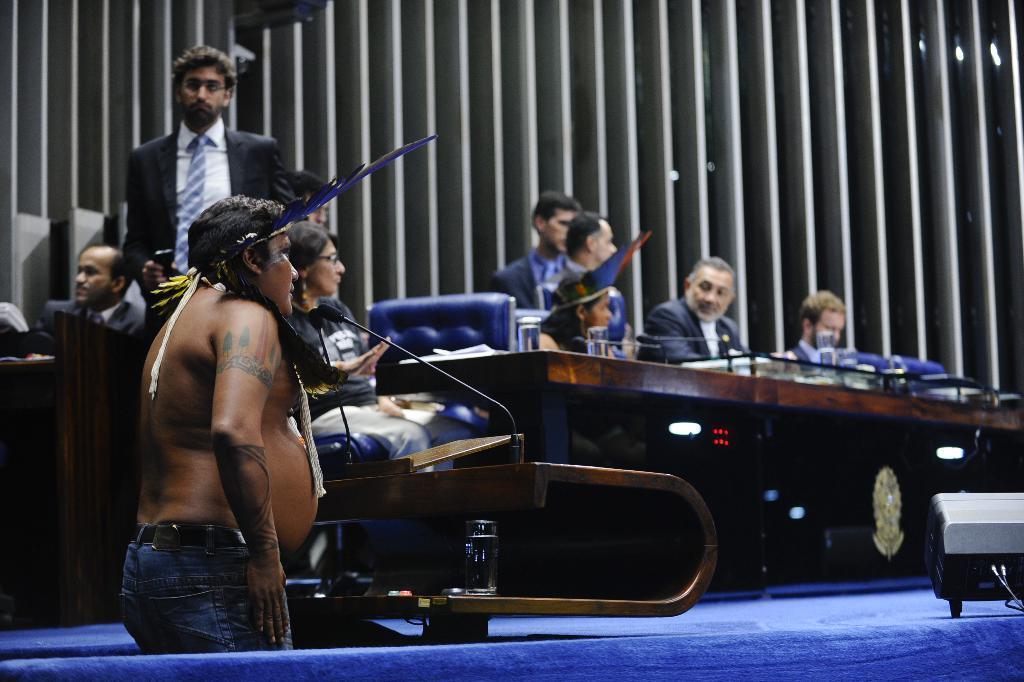Could you give a brief overview of what you see in this image? In this picture I can observe some people sitting on the stage in front of a table. I can observe men and women in this picture. There is a person standing on the left side. I can observe a feather in his ear. In front of him there is a mic. 